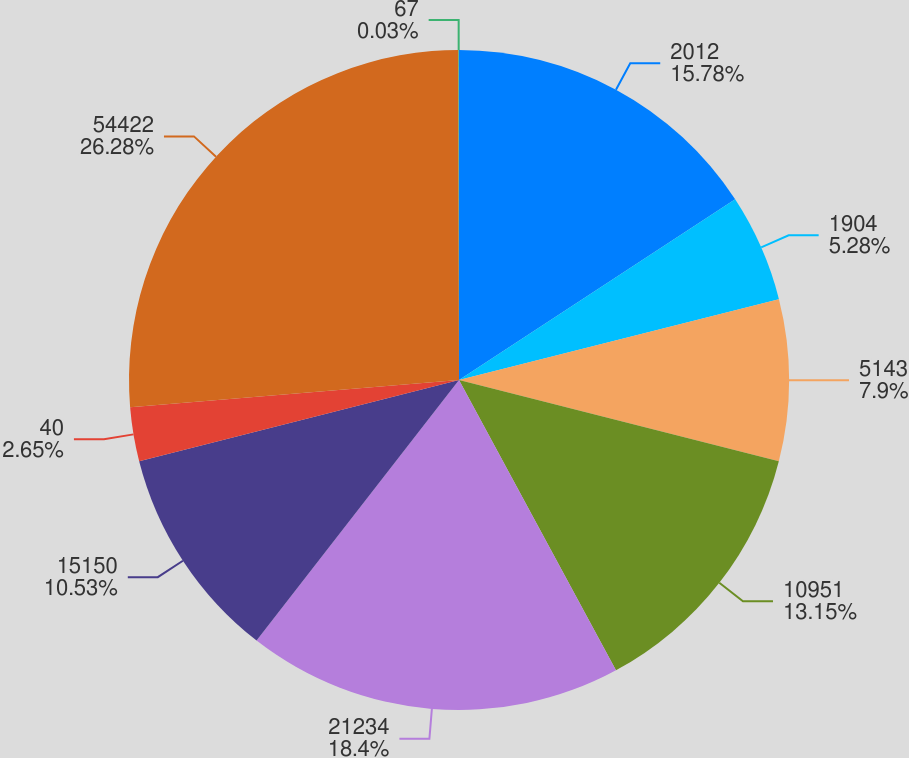Convert chart to OTSL. <chart><loc_0><loc_0><loc_500><loc_500><pie_chart><fcel>2012<fcel>1904<fcel>5143<fcel>10951<fcel>21234<fcel>15150<fcel>40<fcel>54422<fcel>67<nl><fcel>15.78%<fcel>5.28%<fcel>7.9%<fcel>13.15%<fcel>18.4%<fcel>10.53%<fcel>2.65%<fcel>26.28%<fcel>0.03%<nl></chart> 